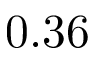Convert formula to latex. <formula><loc_0><loc_0><loc_500><loc_500>0 . 3 6</formula> 